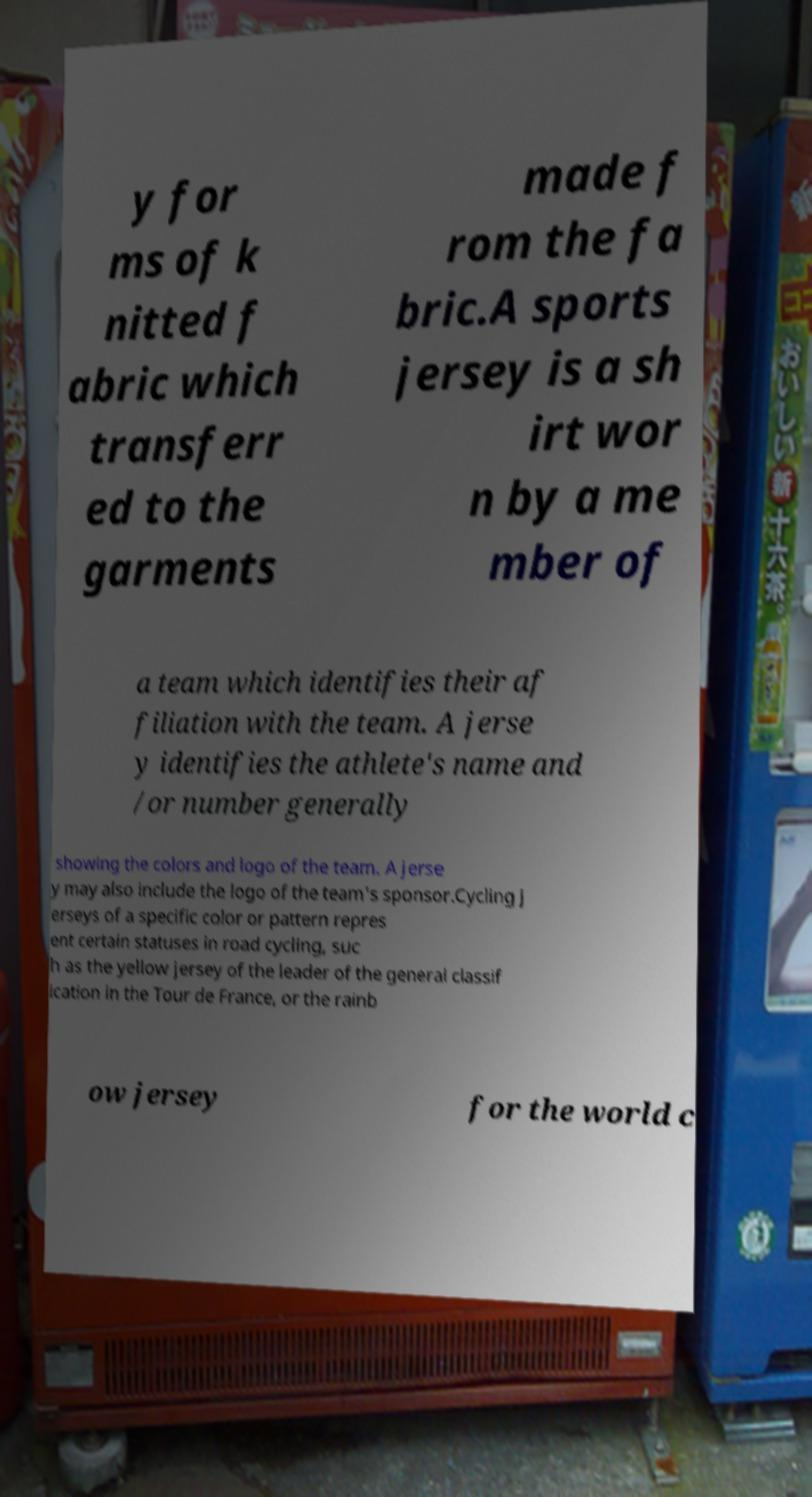What messages or text are displayed in this image? I need them in a readable, typed format. y for ms of k nitted f abric which transferr ed to the garments made f rom the fa bric.A sports jersey is a sh irt wor n by a me mber of a team which identifies their af filiation with the team. A jerse y identifies the athlete's name and /or number generally showing the colors and logo of the team. A jerse y may also include the logo of the team's sponsor.Cycling j erseys of a specific color or pattern repres ent certain statuses in road cycling, suc h as the yellow jersey of the leader of the general classif ication in the Tour de France, or the rainb ow jersey for the world c 